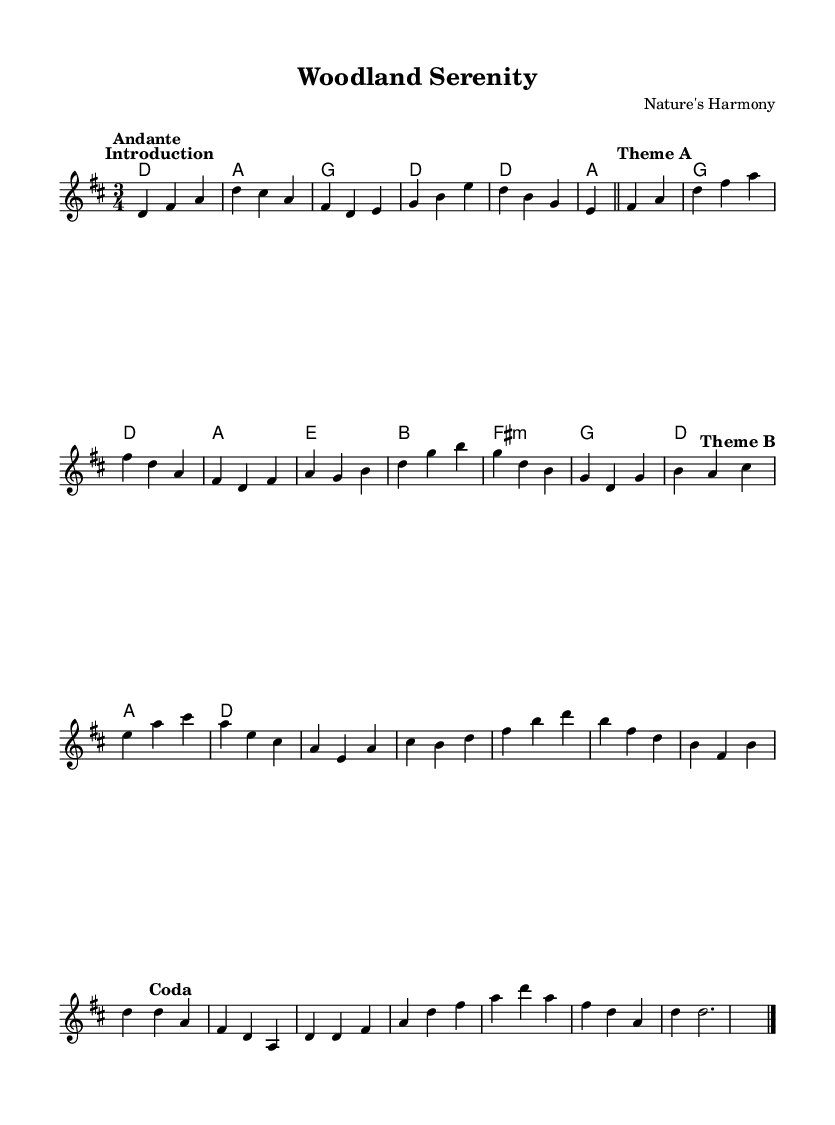What is the key signature of this music? The key signature is D major, which has two sharps (F# and C#). This can be determined by looking at the key signature notation typically placed at the beginning of the staff, which indicates the notes affected by sharps or flats.
Answer: D major What is the time signature of this piece? The time signature is 3/4. This is shown at the beginning of the piece and indicates that there are three beats in each measure and the quarter note gets the beat.
Answer: 3/4 What is the tempo marking for this music? The tempo marking is Andante, which suggests a moderately slow tempo. Tempo markings provide guidance on the speed at which the piece should be played, often written above the staff.
Answer: Andante How many themes are present in this composition? There are two distinct themes identified in the piece, designated as Theme A and Theme B. These are indicated in the music with bold text marks highlighting different sections of the composition, showing its structure.
Answer: Two In which section does the melody first descend to a lower register? The melody first descends to a lower register in the Coda section. This can be observed in the notes' pitch, where the melody shifts to lower notes, demonstrating a downward movement towards the end of the piece.
Answer: Coda Which chord is used as a transition between Theme A and Theme B? The transition chord between Theme A and Theme B is D major. Chords often serve as connections between themes, and in this case, the D major chord appears at the end of Theme A and sets the stage for Theme B.
Answer: D major 